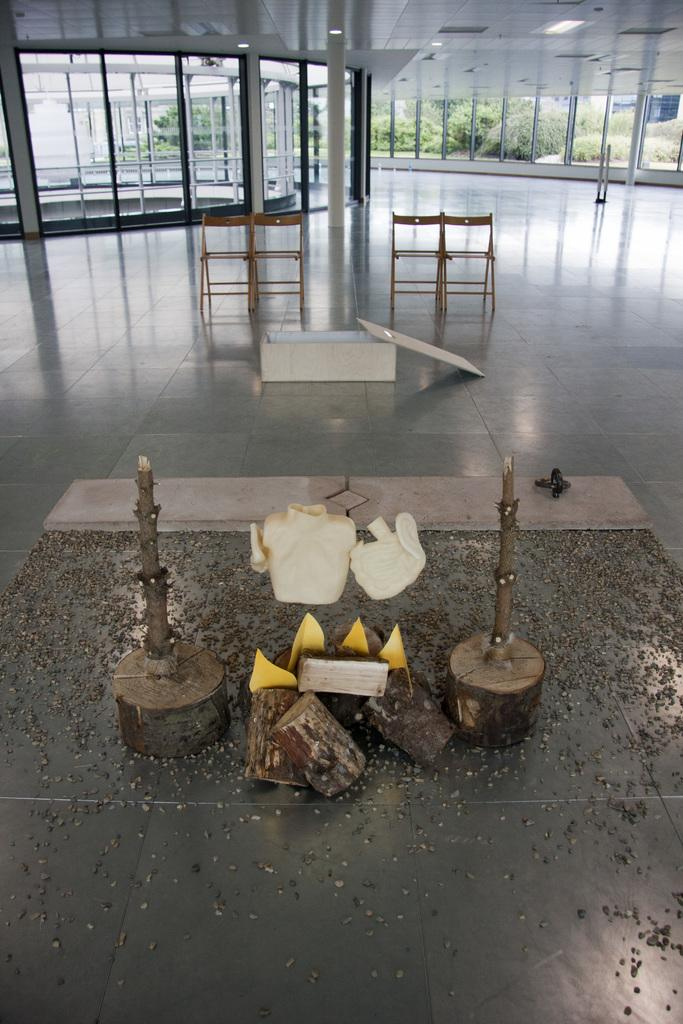What type of furniture is present in the image? There are chairs in the image. What other objects can be seen made of wood? There are wooden trunks in the image. What is on the floor in the image? There is a box on the floor in the image. What can be seen for ventilation or viewing the outdoors? There are windows in the image. What type of wall is present in the image? There is a glass wall in the image. What type of natural scenery is visible in the image? Trees are visible in the image. What type of drink is being served in the image? There is no drink present in the image. Can you see any sea creatures in the image? There is no sea or sea creatures present in the image. Is there a turkey visible in the image? There is no turkey present in the image. 